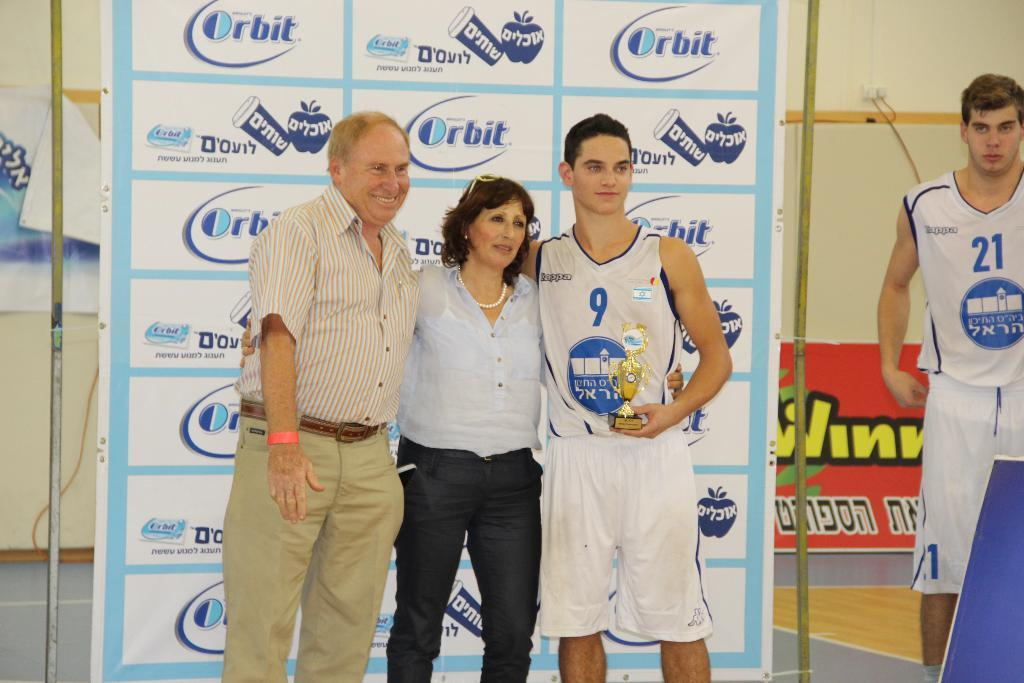<image>
Summarize the visual content of the image. Player number 9 is posing with two people in front of orbit signs. 